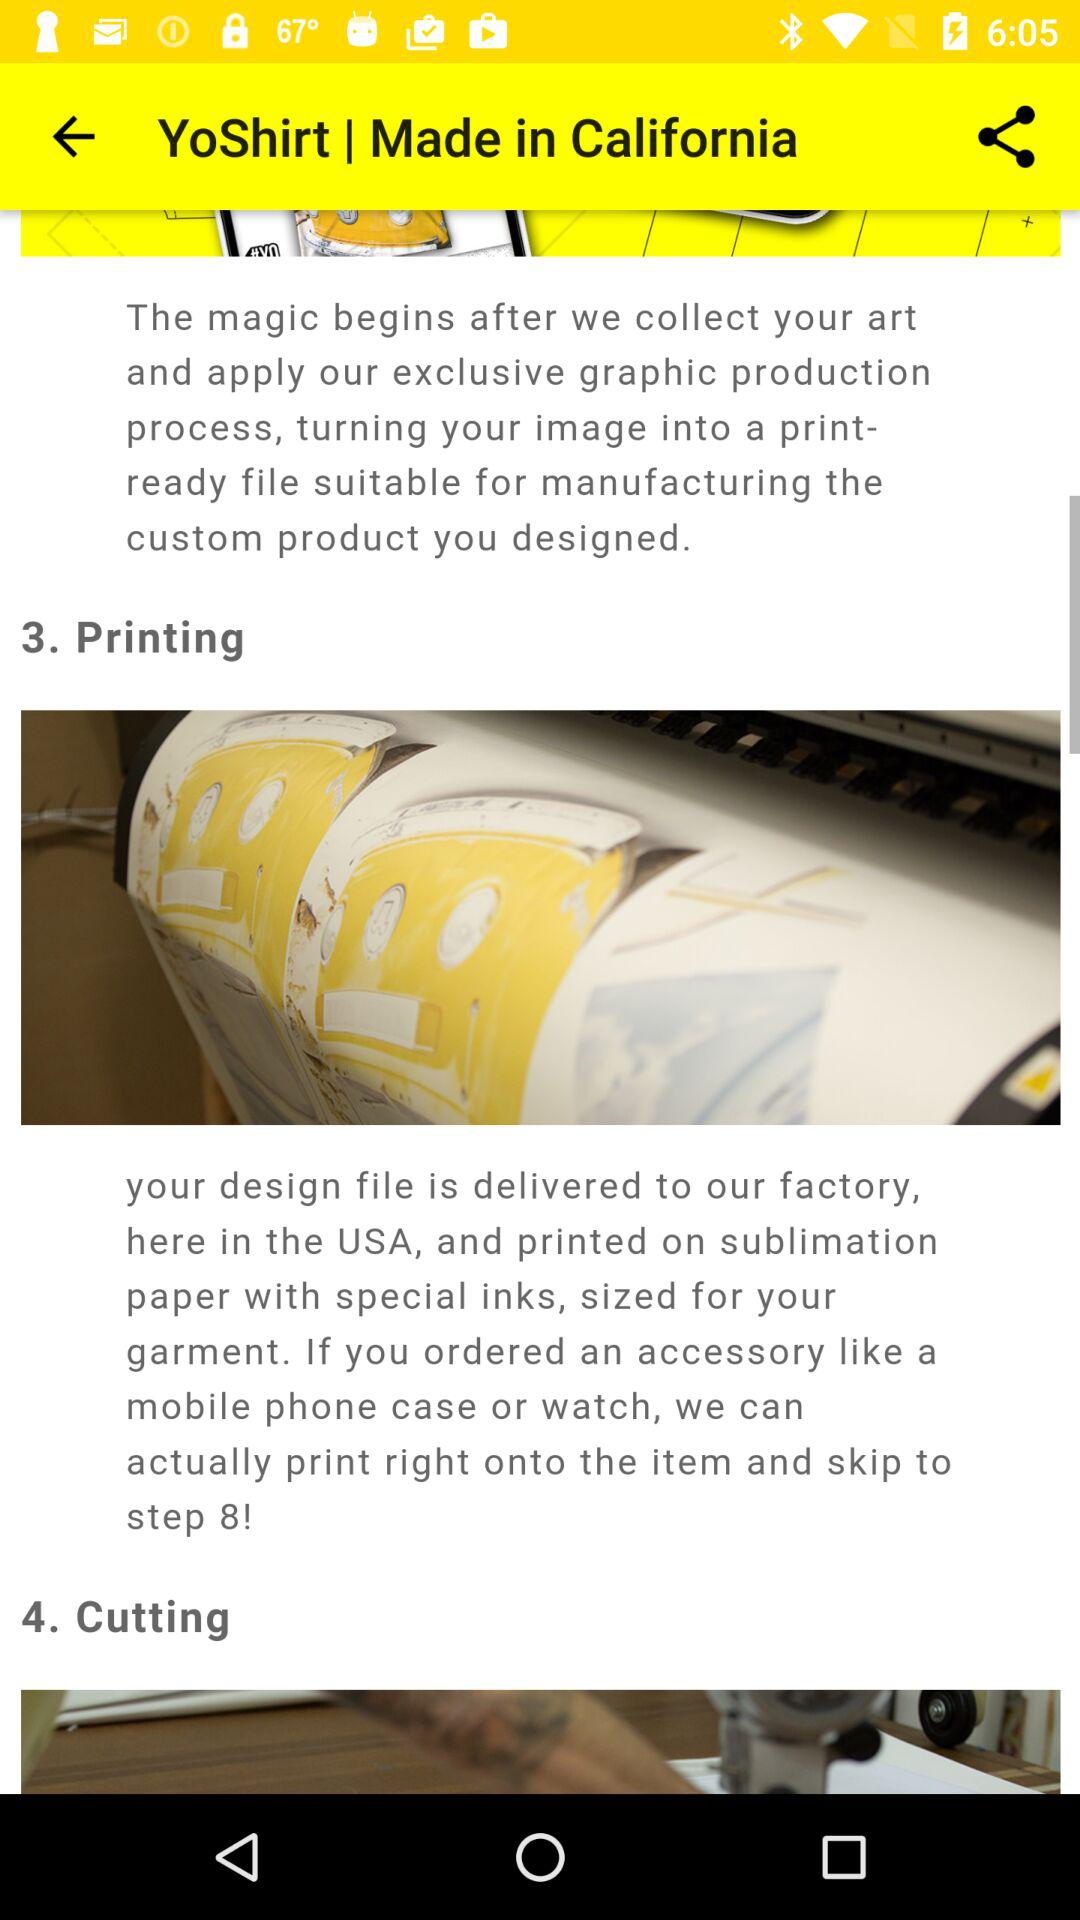How many steps are there in the process?
Answer the question using a single word or phrase. 8 